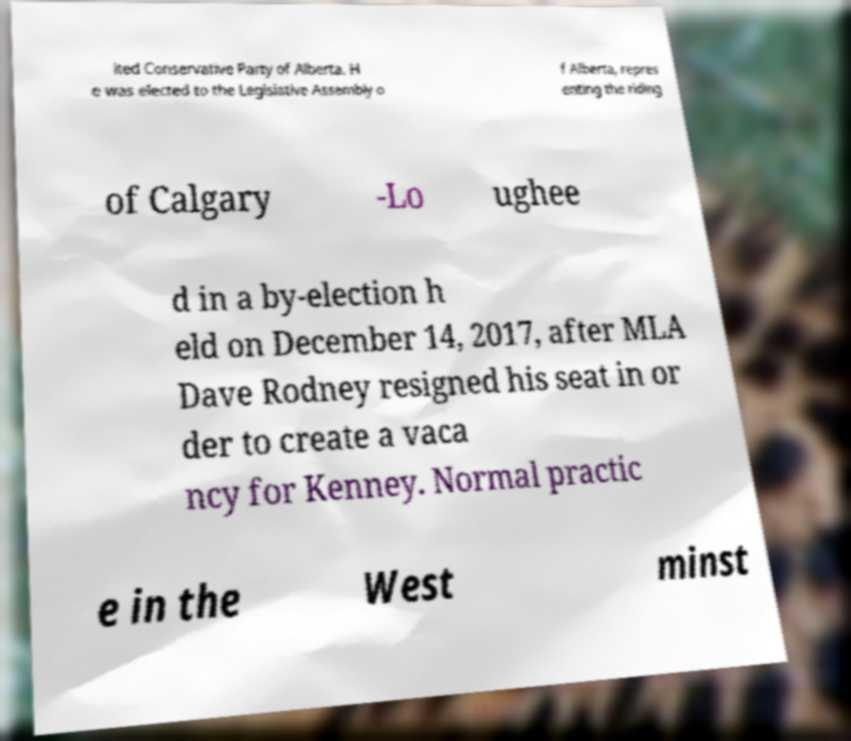Could you assist in decoding the text presented in this image and type it out clearly? ited Conservative Party of Alberta. H e was elected to the Legislative Assembly o f Alberta, repres enting the riding of Calgary -Lo ughee d in a by-election h eld on December 14, 2017, after MLA Dave Rodney resigned his seat in or der to create a vaca ncy for Kenney. Normal practic e in the West minst 